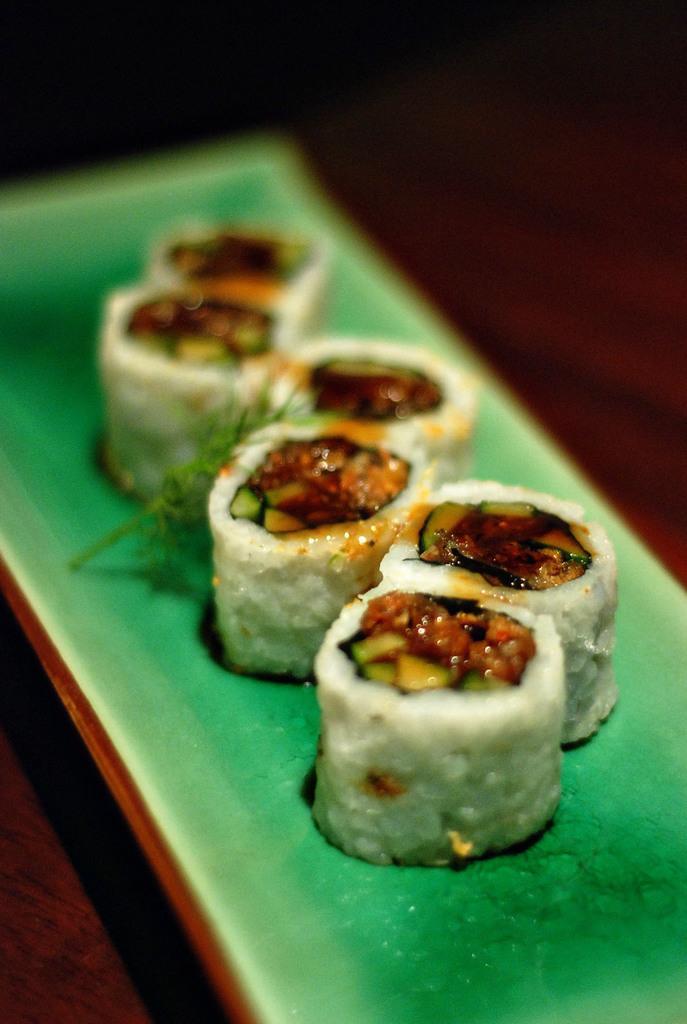Please provide a concise description of this image. In this picture I can see food item on the plate. 